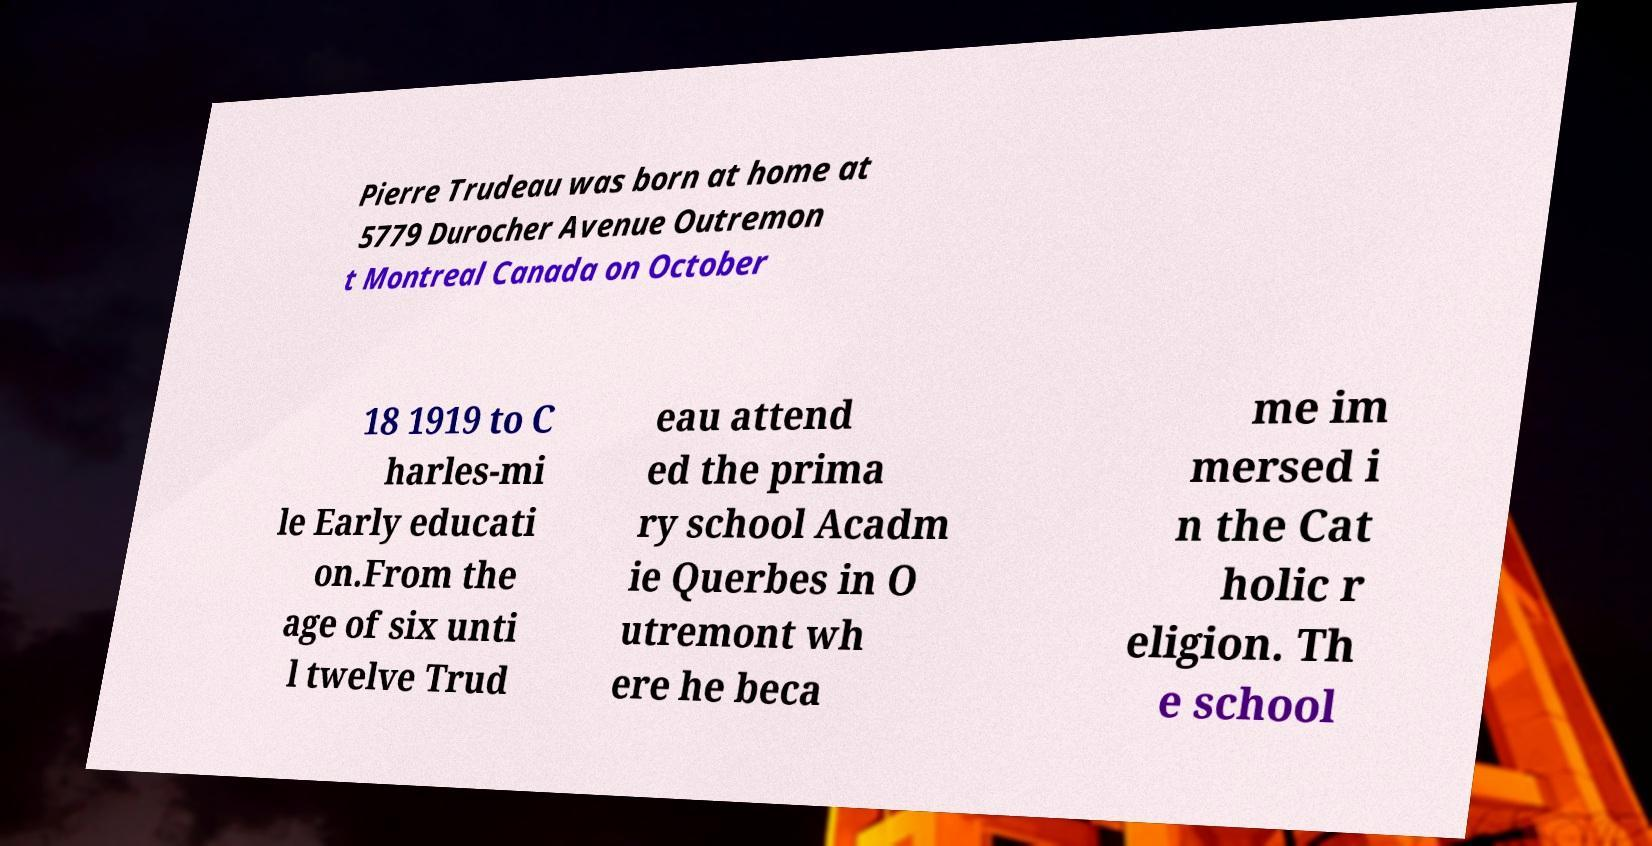For documentation purposes, I need the text within this image transcribed. Could you provide that? Pierre Trudeau was born at home at 5779 Durocher Avenue Outremon t Montreal Canada on October 18 1919 to C harles-mi le Early educati on.From the age of six unti l twelve Trud eau attend ed the prima ry school Acadm ie Querbes in O utremont wh ere he beca me im mersed i n the Cat holic r eligion. Th e school 